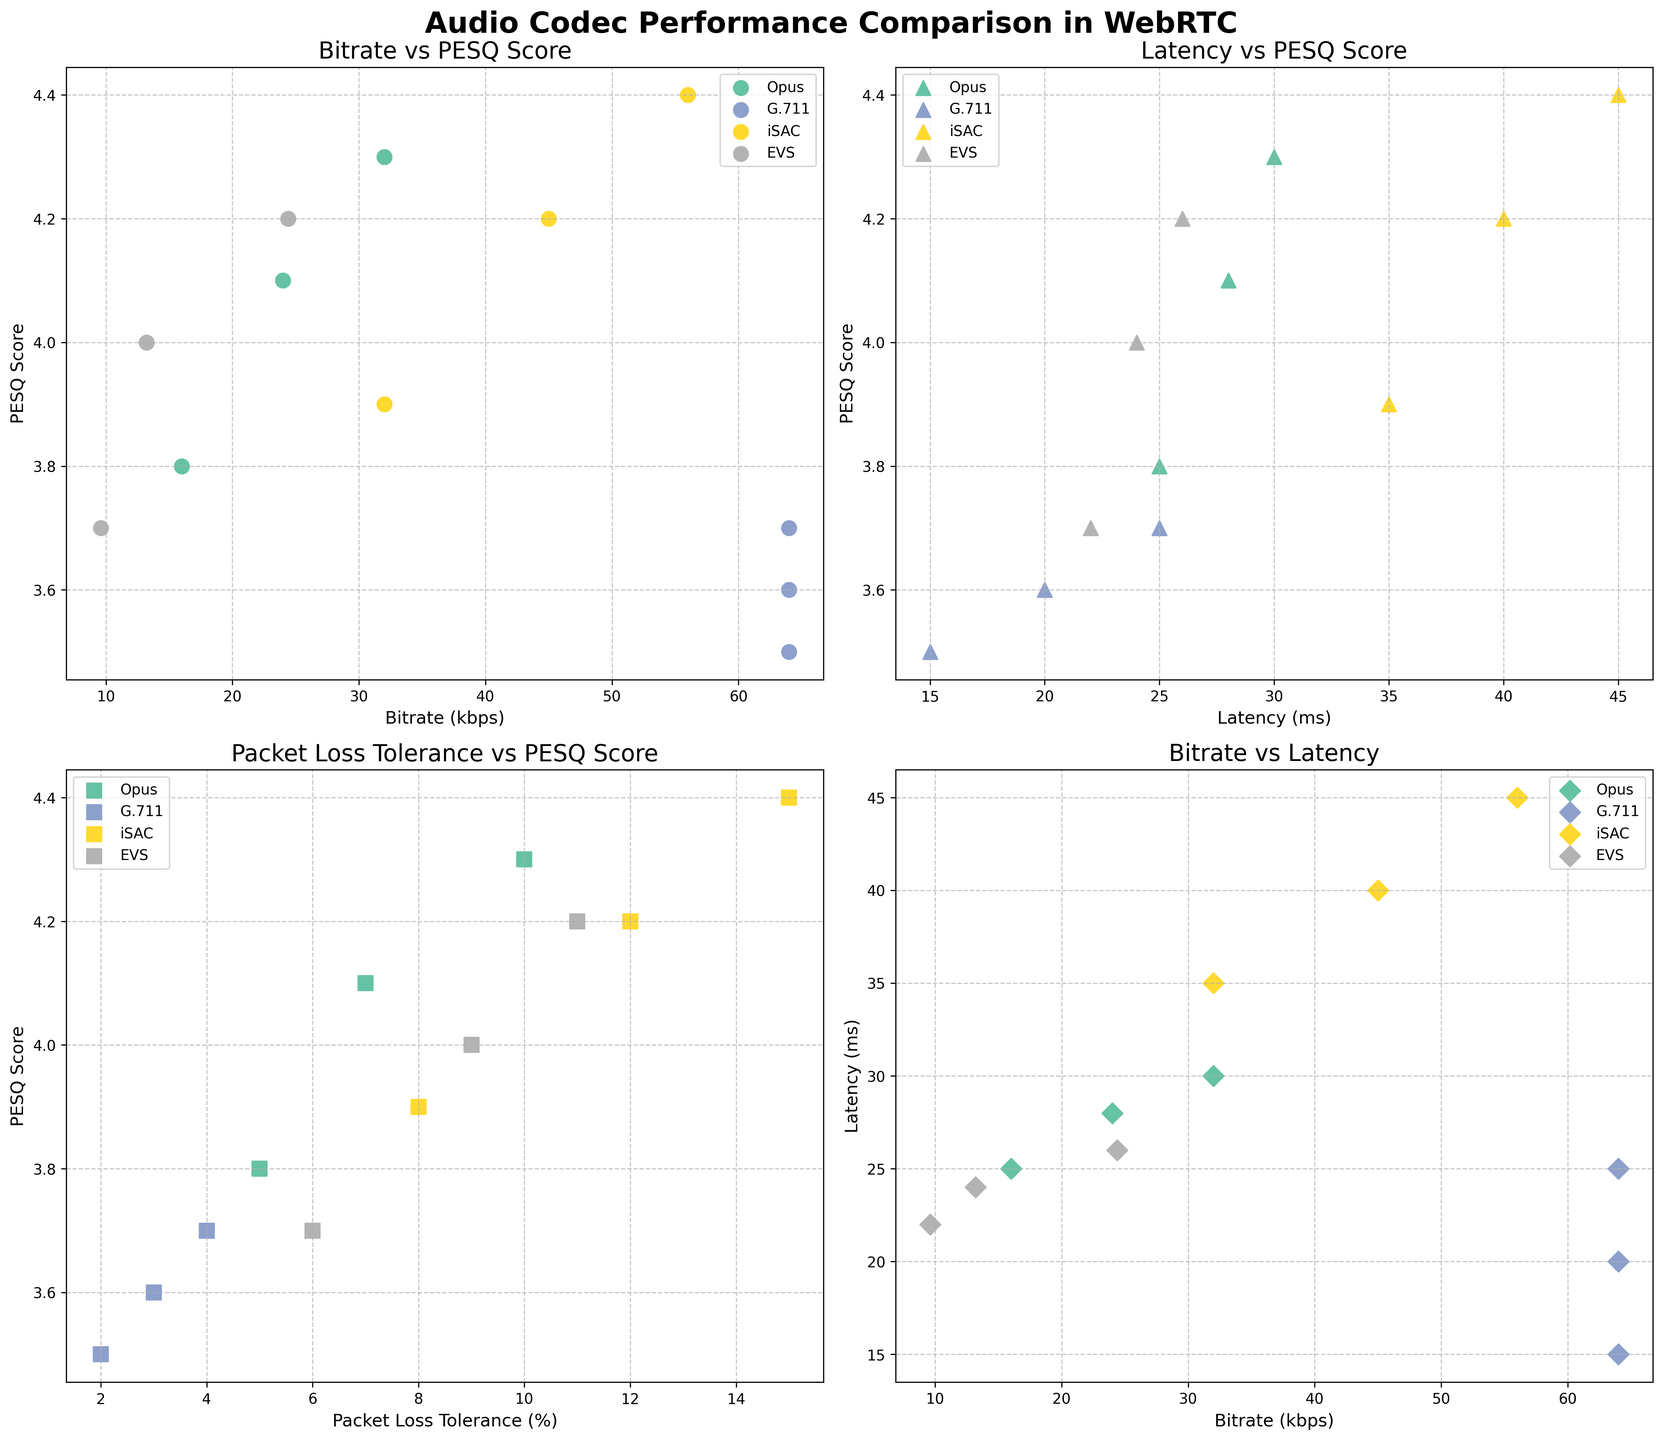what is the title of the figure? The title of the figure is displayed at the top center of the plot. It reads "Audio Codec Performance Comparison in WebRTC".
Answer: Audio Codec Performance Comparison in WebRTC How many data points does the G.711 codec have in the 'Packet Loss Tolerance vs PESQ Score' subplot? By observing the 'Packet Loss Tolerance vs PESQ Score' subplot, we can see three square markers representing the G.711 codec.
Answer: 3 Which codec has the highest PESQ Score at the lowest bitrate? To determine this, look at the 'Bitrate vs PESQ Score' subplot. The highest PESQ Score at the lowest bitrate belongs to the EVS codec at 9.6 kbps with a score of 3.7.
Answer: EVS What is the relationship between Bitrate and Latency for the iSAC codec? By examining the 'Bitrate vs Latency' subplot, we can see that as the bitrate increases, the latency for the iSAC codec also increases.
Answer: As Bitrate increases, Latency increases Between Opus and EVS, which codec performs better at 24 kbps in terms of PESQ Score? Look at the 'Bitrate vs PESQ Score' subplot. For Opus at 24 kbps, the PESQ Score is 4.1, and for EVS at around 24.4 kbps, it is 4.2. Hence, EVS performs slightly better.
Answer: EVS What is the trend between Packet Loss Tolerance and PESQ Score for the Opus codec? By observing the 'Packet Loss Tolerance vs PESQ Score' subplot for Opus, we can see that as Packet Loss Tolerance increases, the PESQ Score also increases.
Answer: As Packet Loss Tolerance increases, PESQ Score increases Compare the Latency at 64 kbps between the Opus and G.711 codecs. In the 'Bitrate vs Latency' subplot, Opus has data points at 16, 24, and 32 kbps, not at 64 kbps. G.711 has three data points at 64 kbps with latencies of 15 ms, 20 ms, and 25 ms, meaning only G.711 codec has data points at 64 kbps in terms of latency, while Opus has none.
Answer: G.711 only 